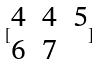<formula> <loc_0><loc_0><loc_500><loc_500>[ \begin{matrix} 4 & 4 & 5 \\ 6 & 7 \end{matrix} ]</formula> 